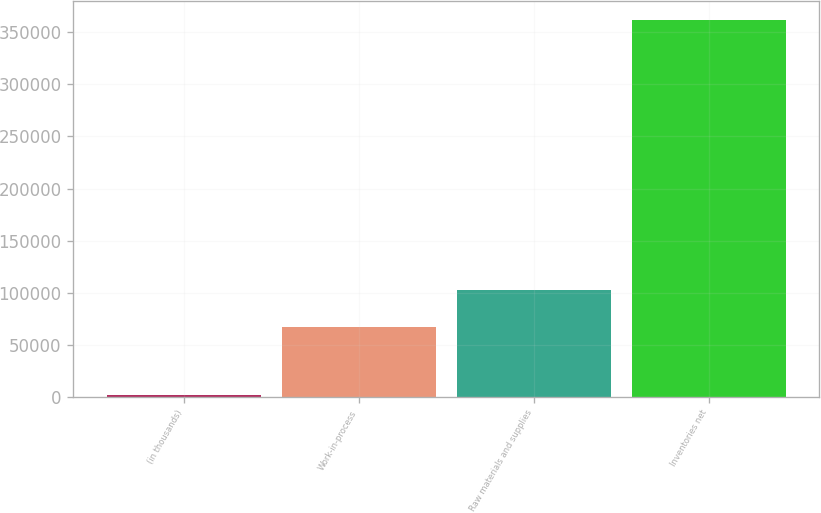Convert chart. <chart><loc_0><loc_0><loc_500><loc_500><bar_chart><fcel>(in thousands)<fcel>Work-in-process<fcel>Raw materials and supplies<fcel>Inventories net<nl><fcel>2011<fcel>66952<fcel>102927<fcel>361762<nl></chart> 